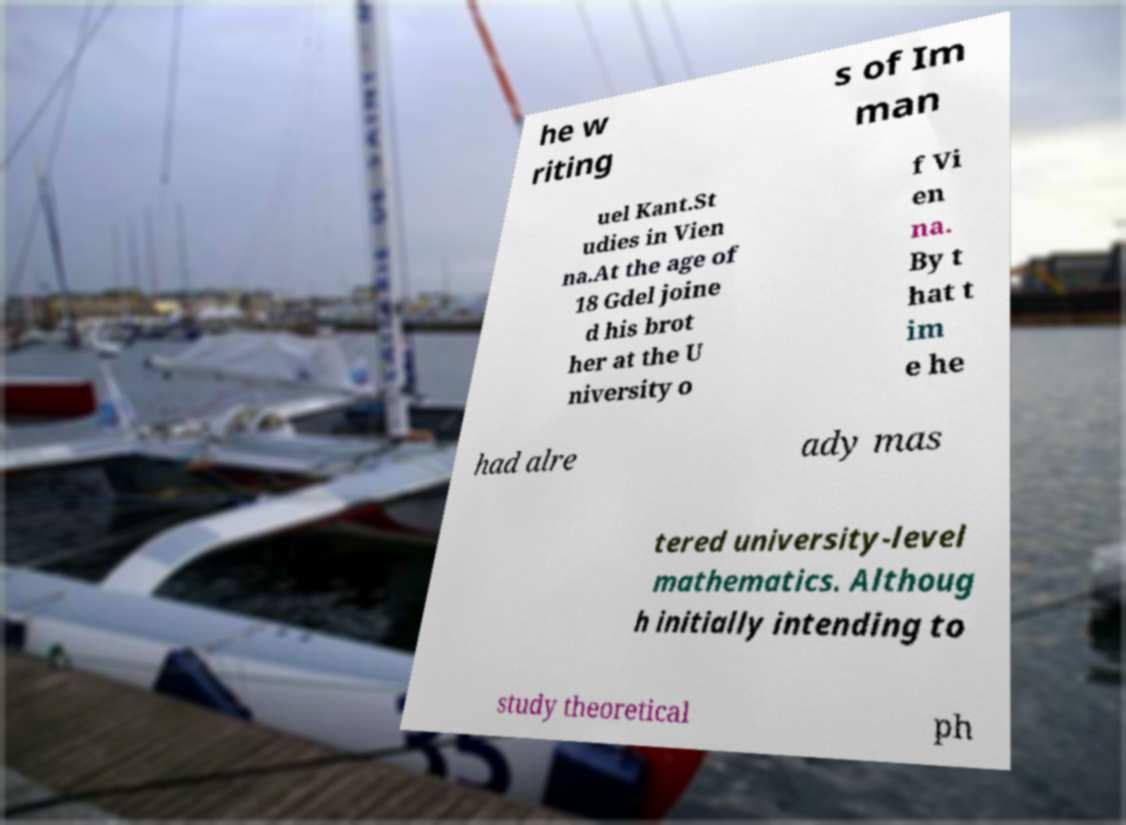Can you accurately transcribe the text from the provided image for me? he w riting s of Im man uel Kant.St udies in Vien na.At the age of 18 Gdel joine d his brot her at the U niversity o f Vi en na. By t hat t im e he had alre ady mas tered university-level mathematics. Althoug h initially intending to study theoretical ph 